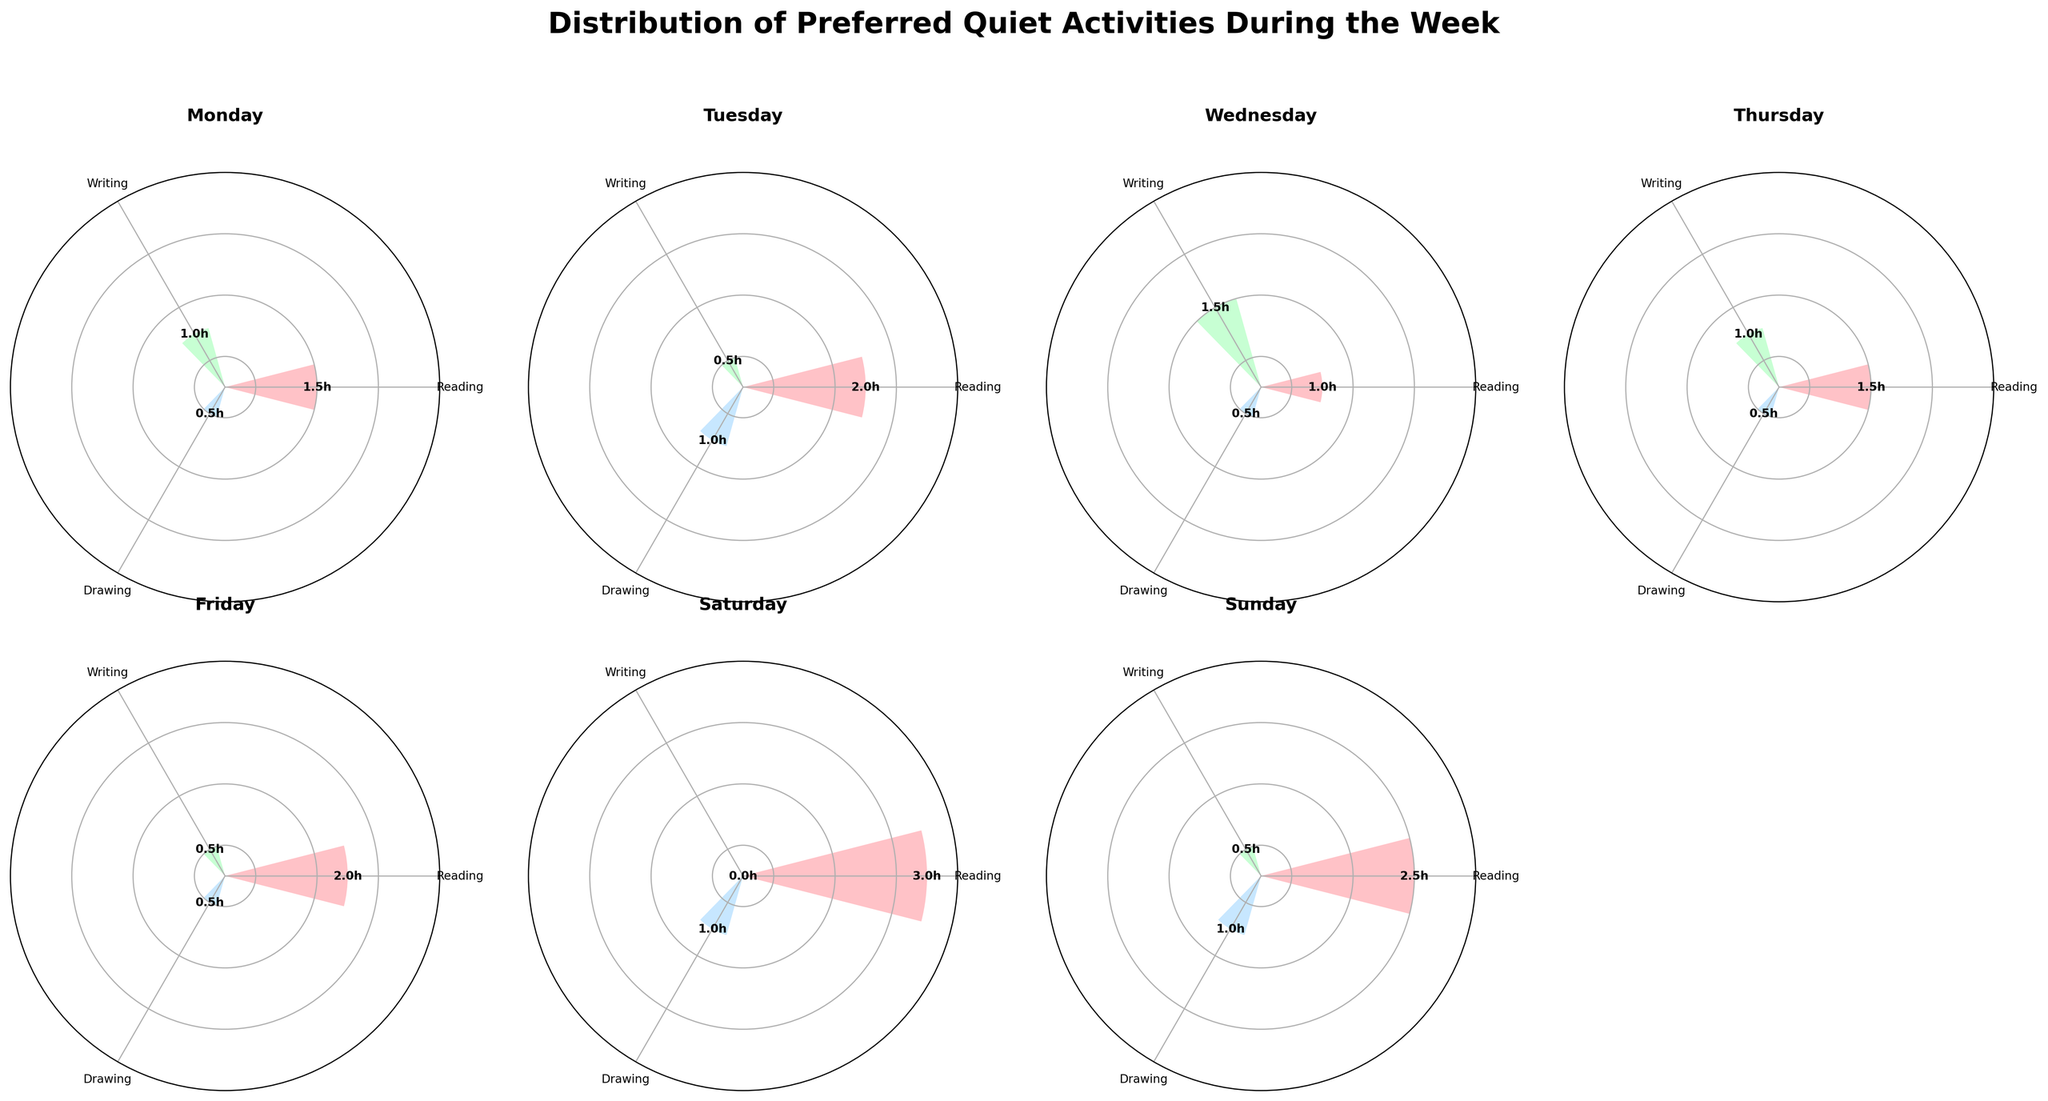Which day has the highest number of hours spent reading? Observing the figure, the day with the highest bar in the Reading section indicates the highest number of hours. The longest bar for Reading is on Saturday.
Answer: Saturday What is the combined total of hours spent on writing and drawing on Tuesday? On Tuesday, the bar for Writing shows 0.5 hours and for Drawing is 1 hour. Adding these gives 0.5 + 1 = 1.5 hours.
Answer: 1.5 hours Which activity has the lowest number of hours on Sunday? On Sunday, the shortest bar indicates the lowest hours spent, which is for Writing at 0.5 hours.
Answer: Writing How much more time is spent reading than writing on Wednesday? On Wednesday, the hours for Reading and Writing are 1 and 1.5 respectively. The difference is 1.5 - 1 = 0.5 hours.
Answer: 0.5 hours What is the average number of hours spent drawing during the week? Adding the hours spent Drawing each day (0.5, 1, 0.5, 0.5, 0.5, 1, 1) gives 5 hours. Dividing this by 7 days, the average is 5 / 7 ≈ 0.71 hours.
Answer: 0.71 hours Which day has the most balanced distribution of hours among all three activities? The day with bars of roughly equal length for all activities is Wednesday, as the heights of Reading, Writing, and Drawing bars are similar.
Answer: Wednesday Is there any day where writing was not done? Observing the figure, on Saturday, the bar for Writing is absent, indicating no hours spent.
Answer: Saturday Which activity sees a significant increase in hours on the weekend compared to weekdays? Comparing bars for Reading throughout the week, it increases significantly on Saturday (3 hours) and Sunday (2.5 hours) compared to weekdays.
Answer: Reading How do the hours spent drawing on Friday compare to that on Thursday? Observing the bars for Drawing, both Thursday and Friday have 0.5 hours each, indicating they are equal.
Answer: Equal What is the total number of hours spent on reading over the week? Summing the Reading hours (1.5, 2, 1, 1.5, 2, 3, 2.5) gives a total of 13.5 hours.
Answer: 13.5 hours 